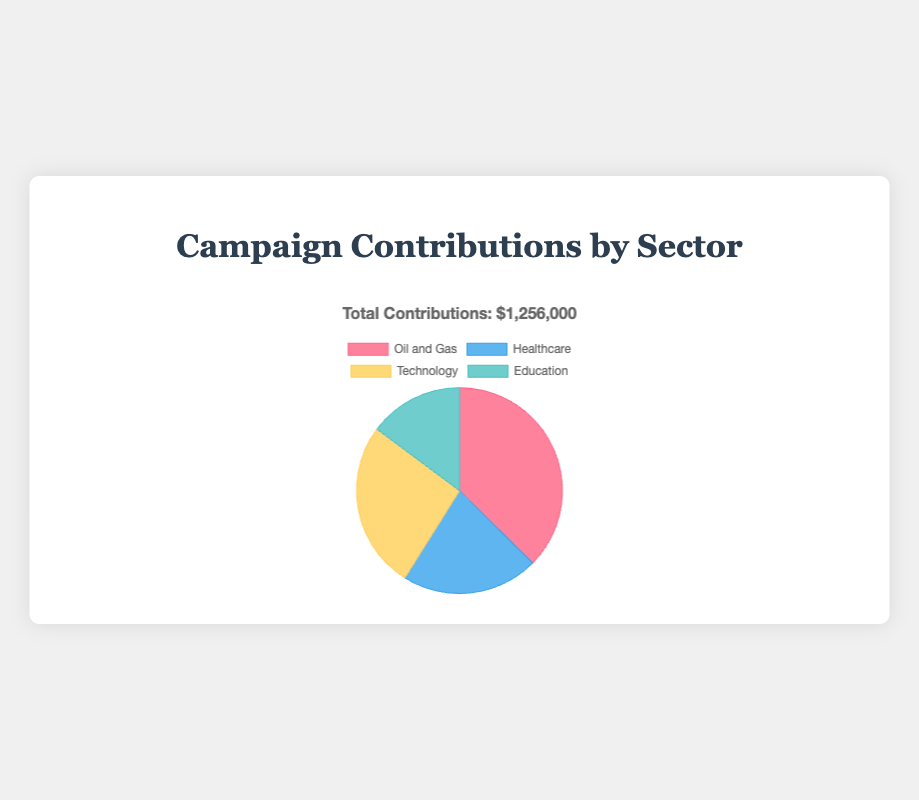What sector has the highest total campaign contributions? The pie chart shows the total contributions of each sector. By comparing the values, "Oil and Gas" has the highest total of $470,000.
Answer: Oil and Gas How much more did the "Oil and Gas" sector contribute compared to the "Healthcare" sector? The total contributions from "Oil and Gas" are $470,000, and from "Healthcare" are $270,000. Subtract the "Healthcare" total from the "Oil and Gas" total: $470,000 - $270,000 = $200,000.
Answer: $200,000 Which sectors contributed less than "Technology"? According to the pie chart, "Technology" contributions total $330,000. Both "Healthcare" ($270,000) and "Education" ($186,000) contributed less.
Answer: Healthcare, Education If the contributions from "Oil and Gas" and "Technology" sectors are combined, what would be the total amount? Sum the contributions from the "Oil and Gas" sector ($470,000) and the "Technology" sector ($330,000): $470,000 + $330,000 = $800,000.
Answer: $800,000 What percentage of the total contributions comes from the "Education" sector? The total contributions sum up to $1,256,000. The contributions from "Education" are $186,000. The percentage is calculated as (186,000 / 1,256,000) * 100 ≈ 14.81%.
Answer: 14.81% Which sector has the smallest slice in the pie chart? Visually, the pie chart shows that the "Education" sector has the smallest slice, with contributions totaling $186,000.
Answer: Education What's the difference between the highest and the lowest sector contributions? The highest contributions come from "Oil and Gas" ($470,000) and the lowest from "Education" ($186,000). The difference is $470,000 - $186,000 = $284,000.
Answer: $284,000 Do "Healthcare" and "Education" together contribute more than "Technology"? Sum the contributions from "Healthcare" ($270,000) and "Education" ($186,000): $270,000 + $186,000 = $456,000. Compare this to "Technology" ($330,000), and we see $456,000 is greater than $330,000.
Answer: Yes 